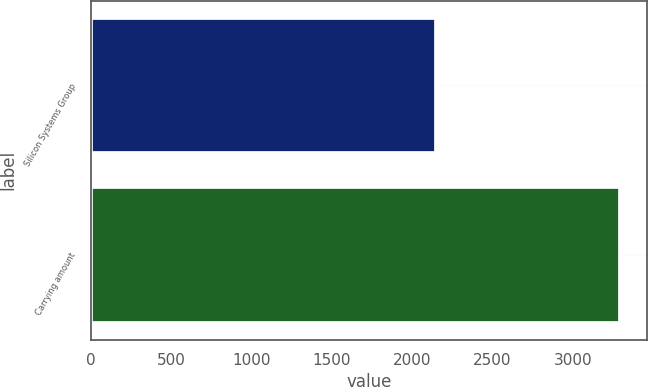Convert chart. <chart><loc_0><loc_0><loc_500><loc_500><bar_chart><fcel>Silicon Systems Group<fcel>Carrying amount<nl><fcel>2151<fcel>3294<nl></chart> 